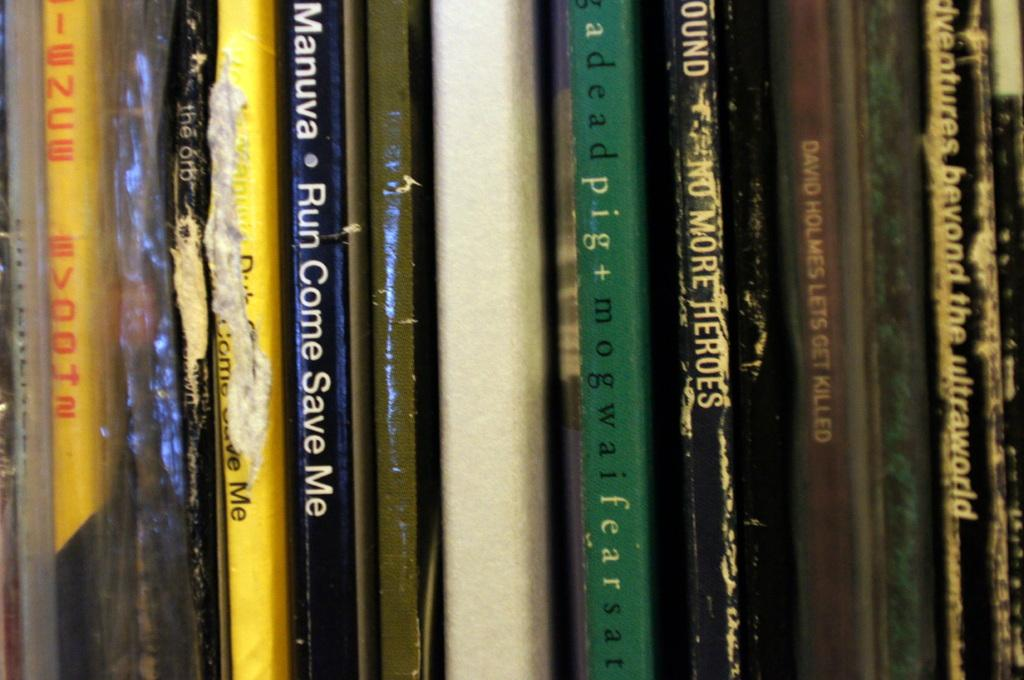<image>
Offer a succinct explanation of the picture presented. A closeup photo of various records, most are cut off but mowgai and david holmes are in the collection. 